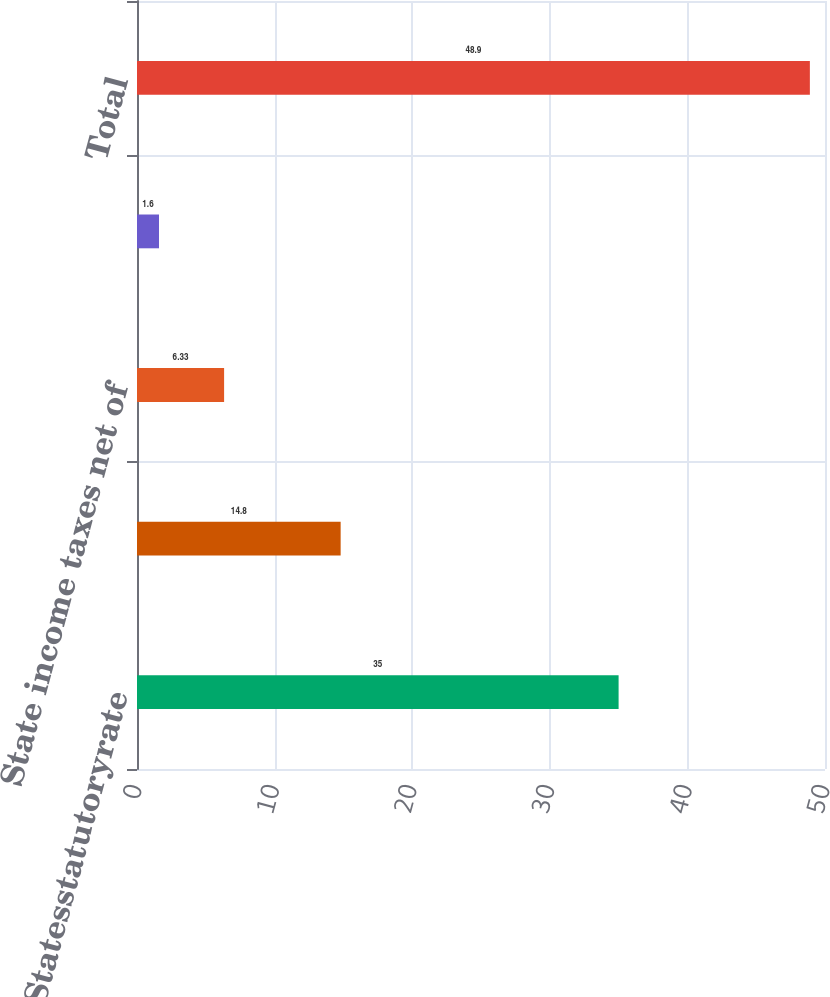Convert chart. <chart><loc_0><loc_0><loc_500><loc_500><bar_chart><fcel>UnitedStatesstatutoryrate<fcel>Effect of foreign operations<fcel>State income taxes net of<fcel>Other<fcel>Total<nl><fcel>35<fcel>14.8<fcel>6.33<fcel>1.6<fcel>48.9<nl></chart> 